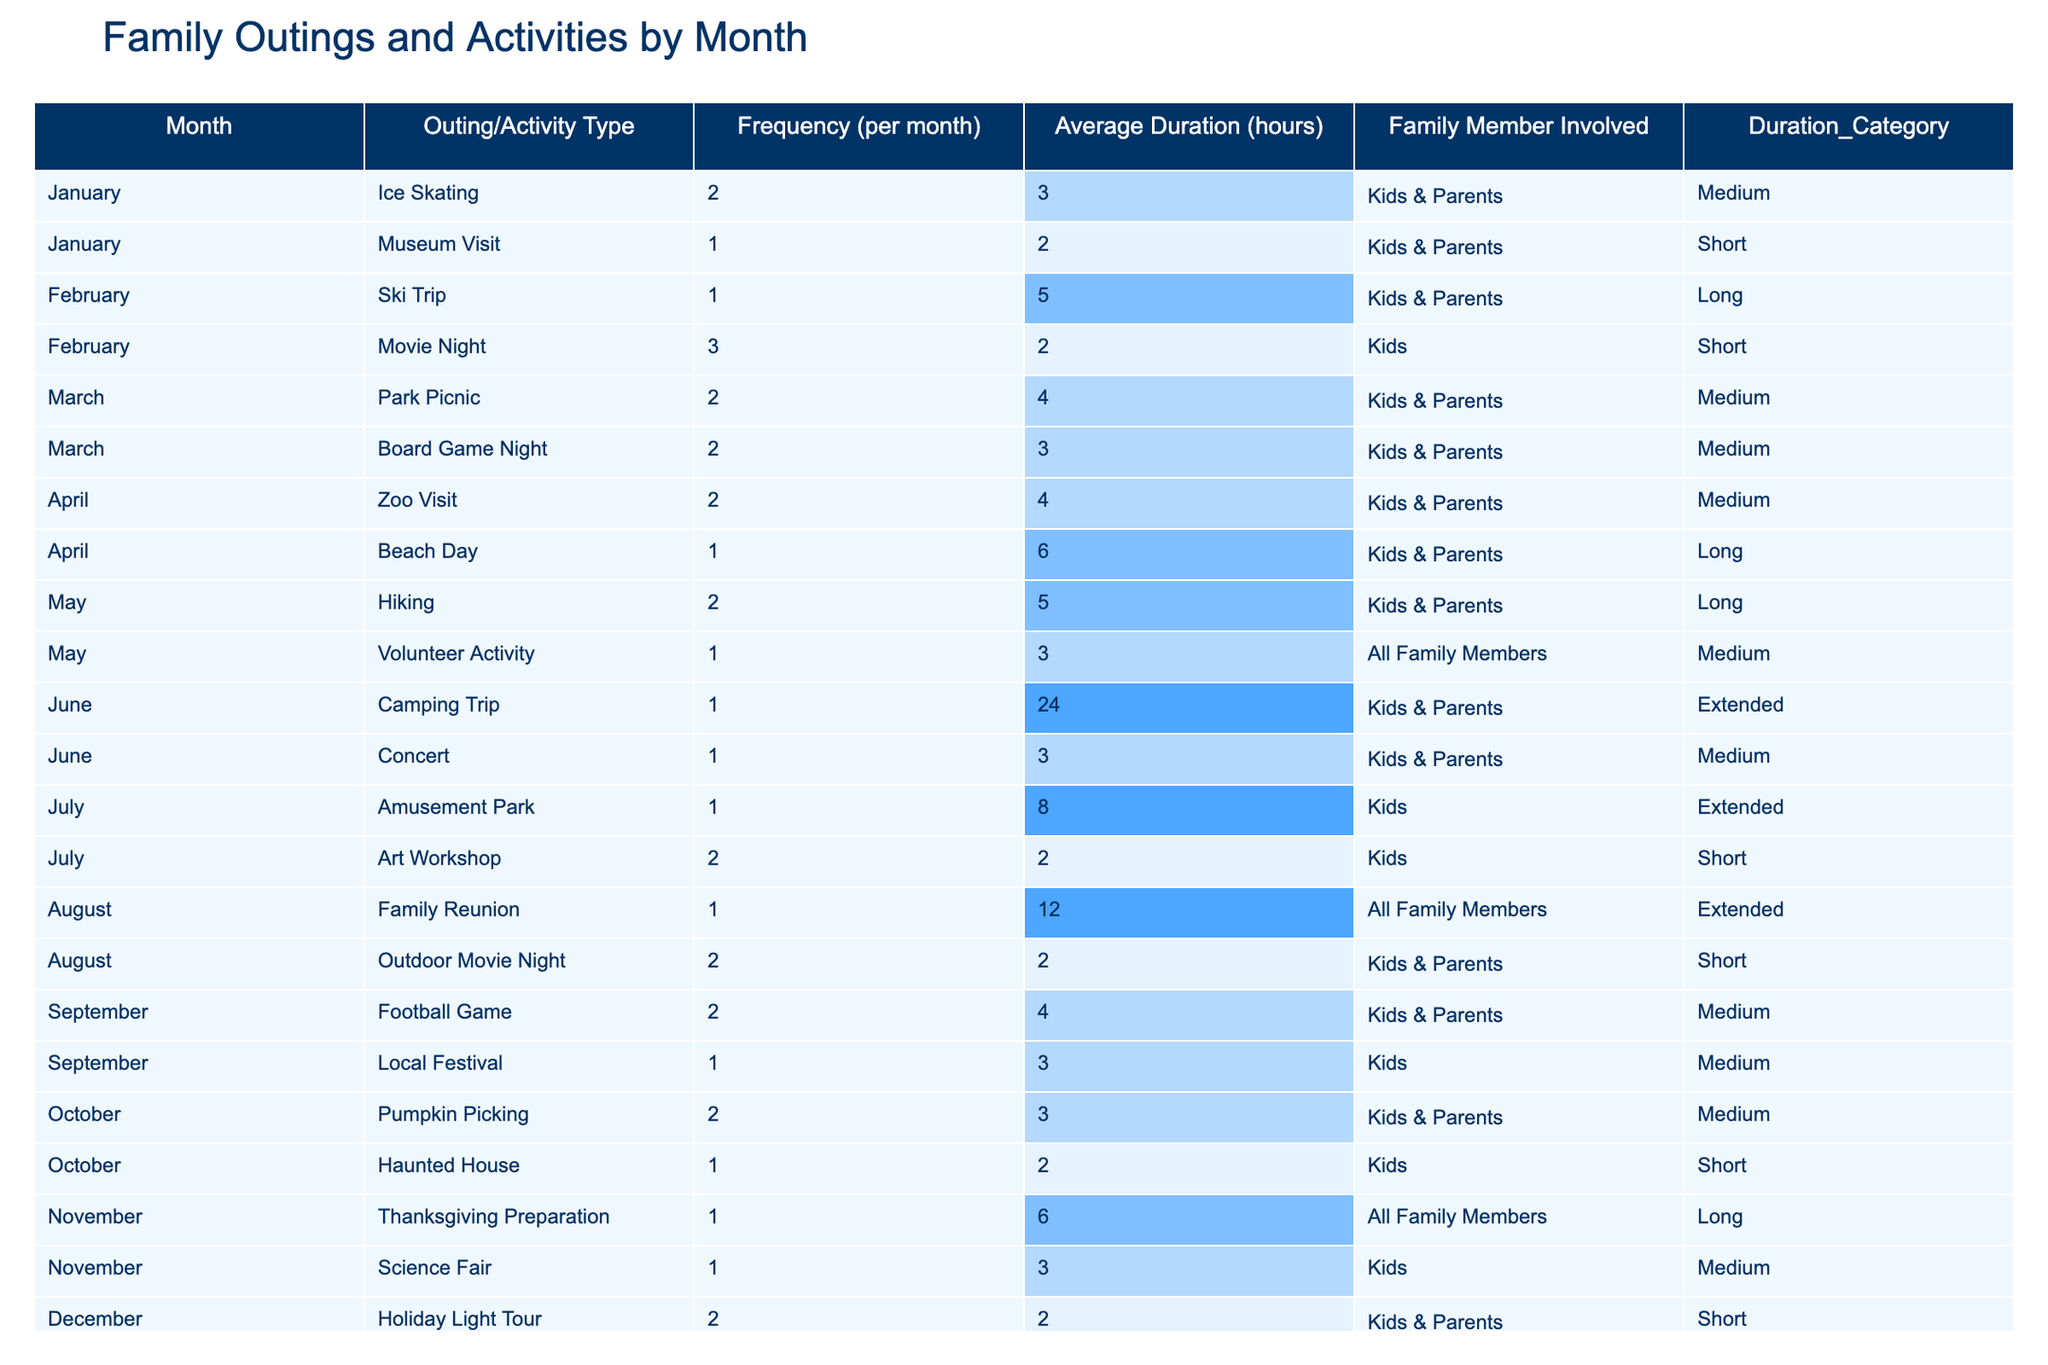What is the most frequent family outing type in July? In July, the table lists two activities: "Amusement Park" with a frequency of 1 and "Art Workshop" with a frequency of 2. Thus, the most frequent activity is "Art Workshop" which occurred 2 times.
Answer: Art Workshop What is the average duration of activities in June? The activities listed in June are "Camping Trip" with a duration of 24 hours and "Concert" with a duration of 3 hours. To find the average, we add these durations (24 + 3 = 27) and divide by the number of activities (2), giving us 27/2 = 13.5 hours.
Answer: 13.5 hours How many outings were planned for February? The table shows two activities for February: "Ski Trip" (1 time) and "Movie Night" (3 times). Adding these gives us a total of 1 + 3 = 4 outings planned for the month.
Answer: 4 outings Which month had the highest average duration of activities? To determine the highest average duration, we look at the average duration for each month and compare them. The maximum is found in June with an average duration of 13.5 hours from activities listed.
Answer: June Was there a family outing in August involving all family members? The table indicates one outing for August, "Family Reunion," which involves all family members. Thus, this statement is true.
Answer: Yes How many total activities involved kids in December? In December, there are two activities: "Holiday Light Tour" and "Cookie Baking," both of which involve kids & parents. Therefore, total activities involving kids are 2.
Answer: 2 activities What is the total frequency of family outings in the first half of the year (January to June)? By summing the frequencies for each month from January to June: January (3) + February (4) + March (4) + April (3) + May (3) + June (2) = 19. Hence, the total frequency of outings for this period is 19.
Answer: 19 Which month had the least number of family activities? Looking through the table month by month, August with "Family Reunion" (1) and "Outdoor Movie Night" (2) sums to 3 activities, which is the lowest compared to others.
Answer: August Did family outings frequency increase from January to April? Checking the frequencies: January (3), February (4), March (4), April (3) shows there is no consistent increase, as it goes from 3 to 4, back to 3, indicating fluctuating participation.
Answer: No 